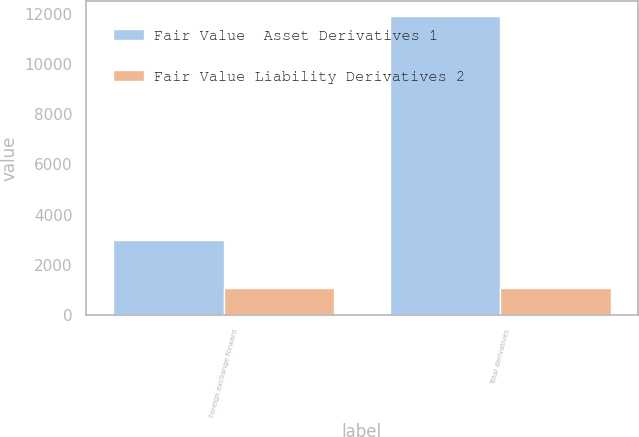Convert chart. <chart><loc_0><loc_0><loc_500><loc_500><stacked_bar_chart><ecel><fcel>Foreign exchange forward<fcel>Total derivatives<nl><fcel>Fair Value  Asset Derivatives 1<fcel>2978<fcel>11891<nl><fcel>Fair Value Liability Derivatives 2<fcel>1067<fcel>1067<nl></chart> 